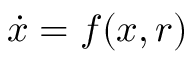Convert formula to latex. <formula><loc_0><loc_0><loc_500><loc_500>{ \dot { x } } = f ( x , r )</formula> 